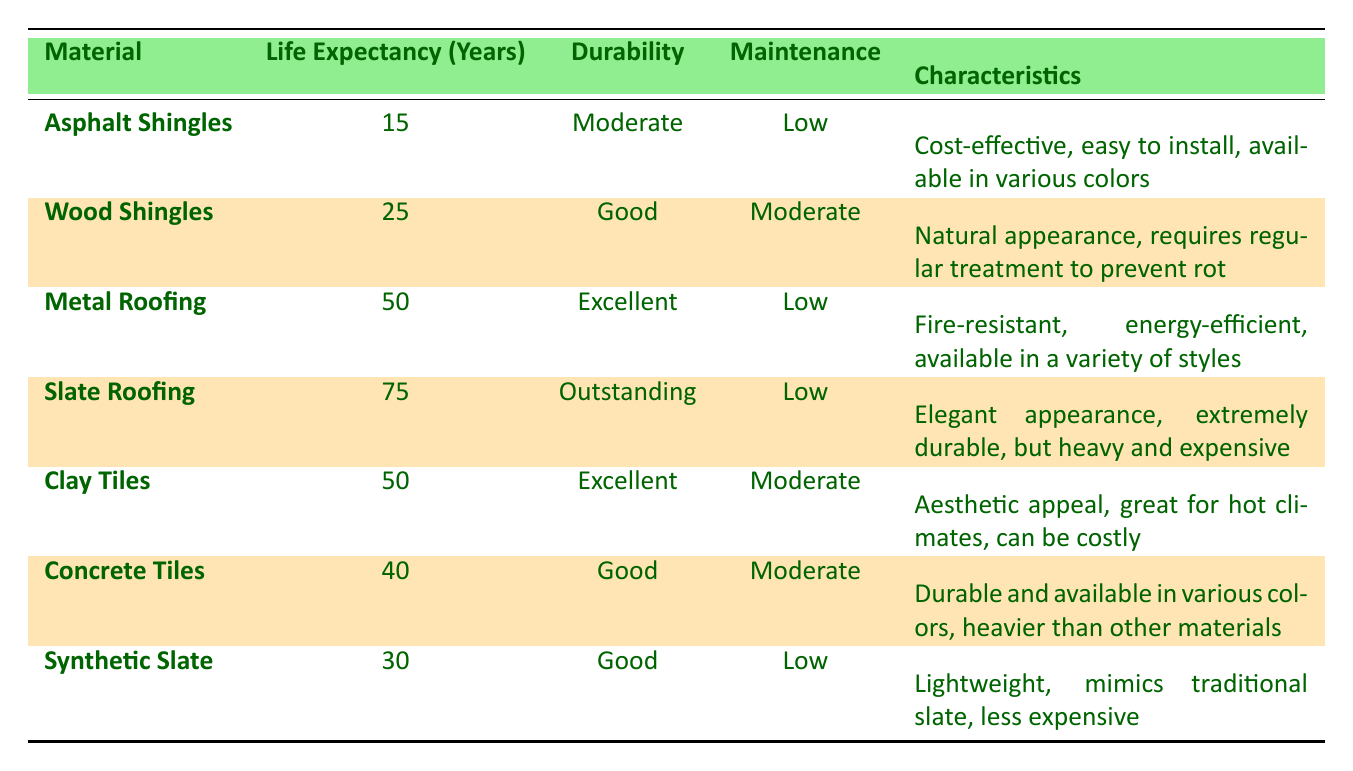What is the life expectancy of metal roofing? From the table, metal roofing has a life expectancy listed as 50 years.
Answer: 50 years Which roofing material has the highest durability rating? According to the durability column, slate roofing is described as "Outstanding," which is the highest rating provided among the materials listed.
Answer: Slate roofing What is the maintenance level of clay tiles? The maintenance column shows that clay tiles require "Moderate" maintenance.
Answer: Moderate What is the average life expectancy of wood shingles and concrete tiles? The life expectancy for wood shingles is 25 years and for concrete tiles, it is 40 years. Adding these gives 25 + 40 = 65 years. Then, divide by the number of materials (2): 65 / 2 = 32.5 years.
Answer: 32.5 years Are asphalt shingles the most cost-effective option for roofing? The table highlights asphalt shingles as "cost-effective," but does not provide cost comparisons with other materials. Therefore, based only on the table, yes, asphalt shingles can be considered cost-effective.
Answer: Yes Which material has the lowest life expectancy? The life expectancies listed are: Asphalt Shingles - 15 years, Wood Shingles - 25 years, Metal Roofing - 50 years, Slate Roofing - 75 years, Clay Tiles - 50 years, Concrete Tiles - 40 years, and Synthetic Slate - 30 years. Asphalt shingles have the lowest life expectancy at 15 years.
Answer: Asphalt Shingles Is synthetic slate lighter than wood shingles? The characteristics section states that synthetic slate is "Lightweight," while wood shingles require regular treatment to prevent rot, with no specific weight mentioned. Thus, we cannot conclusively determine that synthetic slate is lighter than wood shingles based solely on this table.
Answer: Cannot determine What is the difference in life expectancy between slate roofing and synthetic slate? The life expectancy of slate roofing is 75 years, while for synthetic slate, it is 30 years. The difference is 75 - 30 = 45 years.
Answer: 45 years How many roofing materials require low maintenance? Reviewing the maintenance levels, it shows that asphalt shingles, metal roofing, slate roofing, and synthetic slate require "Low" maintenance, totaling to 4 materials.
Answer: 4 materials 